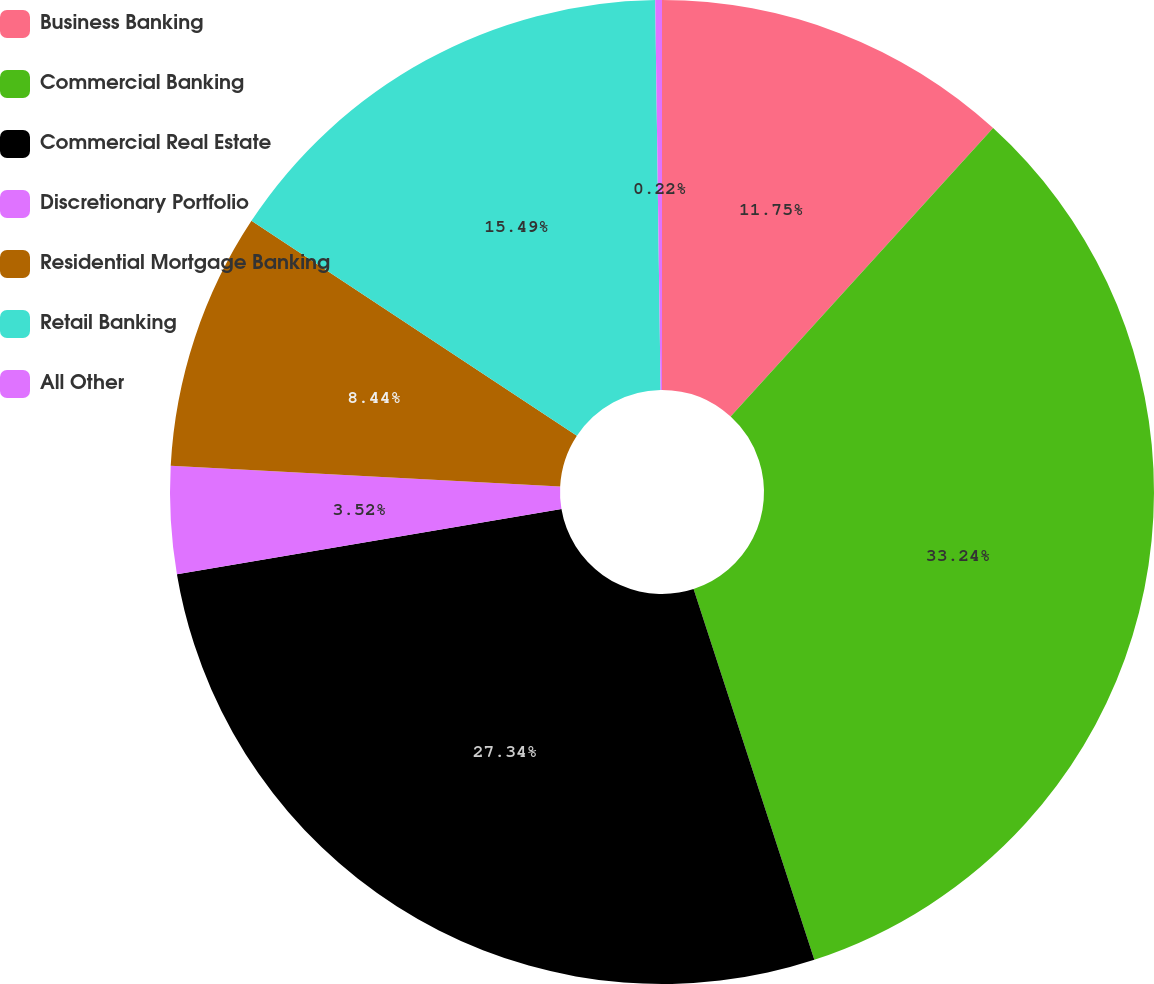Convert chart to OTSL. <chart><loc_0><loc_0><loc_500><loc_500><pie_chart><fcel>Business Banking<fcel>Commercial Banking<fcel>Commercial Real Estate<fcel>Discretionary Portfolio<fcel>Residential Mortgage Banking<fcel>Retail Banking<fcel>All Other<nl><fcel>11.75%<fcel>33.24%<fcel>27.34%<fcel>3.52%<fcel>8.44%<fcel>15.49%<fcel>0.22%<nl></chart> 